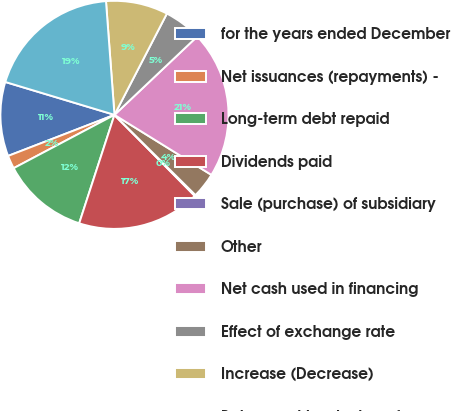Convert chart to OTSL. <chart><loc_0><loc_0><loc_500><loc_500><pie_chart><fcel>for the years ended December<fcel>Net issuances (repayments) -<fcel>Long-term debt repaid<fcel>Dividends paid<fcel>Sale (purchase) of subsidiary<fcel>Other<fcel>Net cash used in financing<fcel>Effect of exchange rate<fcel>Increase (Decrease)<fcel>Balance at beginning of year<nl><fcel>10.52%<fcel>1.88%<fcel>12.25%<fcel>17.43%<fcel>0.15%<fcel>3.6%<fcel>20.89%<fcel>5.33%<fcel>8.79%<fcel>19.16%<nl></chart> 